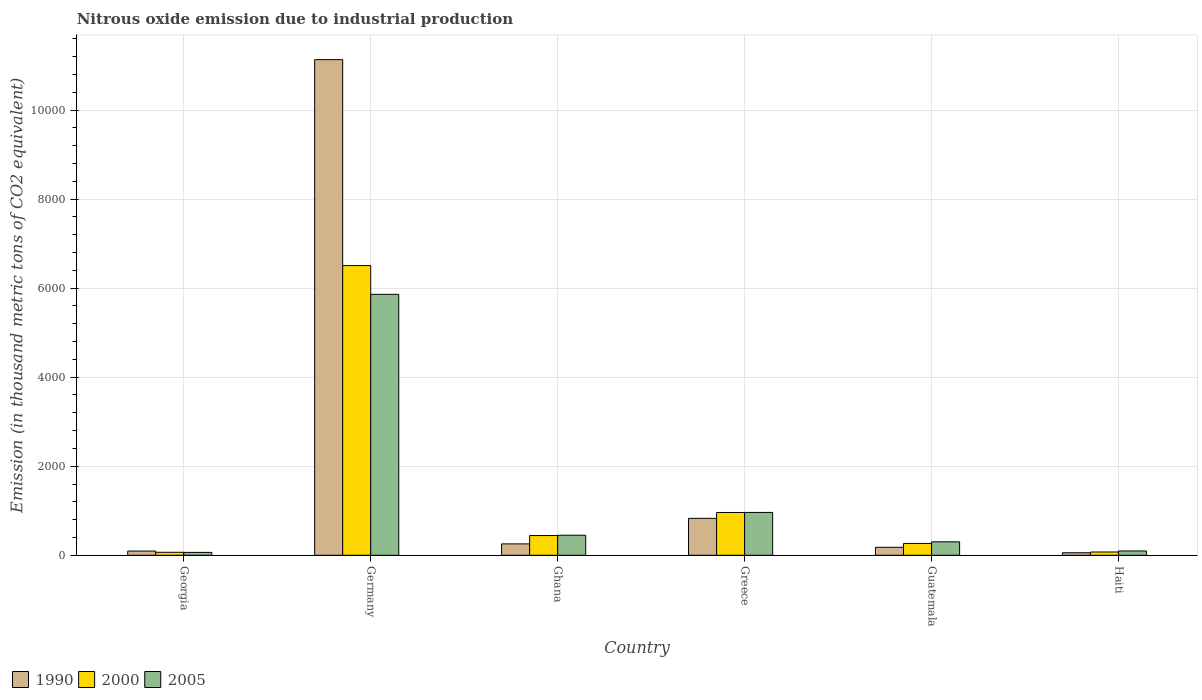How many different coloured bars are there?
Ensure brevity in your answer.  3. Are the number of bars per tick equal to the number of legend labels?
Offer a very short reply. Yes. How many bars are there on the 4th tick from the right?
Your response must be concise. 3. What is the label of the 5th group of bars from the left?
Make the answer very short. Guatemala. In how many cases, is the number of bars for a given country not equal to the number of legend labels?
Make the answer very short. 0. What is the amount of nitrous oxide emitted in 2000 in Haiti?
Provide a succinct answer. 73.8. Across all countries, what is the maximum amount of nitrous oxide emitted in 1990?
Provide a succinct answer. 1.11e+04. Across all countries, what is the minimum amount of nitrous oxide emitted in 2005?
Provide a short and direct response. 64.5. In which country was the amount of nitrous oxide emitted in 2005 maximum?
Offer a terse response. Germany. In which country was the amount of nitrous oxide emitted in 1990 minimum?
Ensure brevity in your answer.  Haiti. What is the total amount of nitrous oxide emitted in 2000 in the graph?
Keep it short and to the point. 8317.5. What is the difference between the amount of nitrous oxide emitted in 2000 in Germany and that in Greece?
Provide a short and direct response. 5546.2. What is the difference between the amount of nitrous oxide emitted in 1990 in Georgia and the amount of nitrous oxide emitted in 2005 in Guatemala?
Provide a succinct answer. -207.2. What is the average amount of nitrous oxide emitted in 1990 per country?
Provide a succinct answer. 2091.42. What is the difference between the amount of nitrous oxide emitted of/in 2005 and amount of nitrous oxide emitted of/in 2000 in Greece?
Offer a terse response. 1.7. What is the ratio of the amount of nitrous oxide emitted in 1990 in Georgia to that in Haiti?
Give a very brief answer. 1.68. Is the amount of nitrous oxide emitted in 2000 in Georgia less than that in Ghana?
Your response must be concise. Yes. Is the difference between the amount of nitrous oxide emitted in 2005 in Georgia and Germany greater than the difference between the amount of nitrous oxide emitted in 2000 in Georgia and Germany?
Give a very brief answer. Yes. What is the difference between the highest and the second highest amount of nitrous oxide emitted in 2000?
Ensure brevity in your answer.  -5546.2. What is the difference between the highest and the lowest amount of nitrous oxide emitted in 2000?
Your answer should be compact. 6439.8. In how many countries, is the amount of nitrous oxide emitted in 2000 greater than the average amount of nitrous oxide emitted in 2000 taken over all countries?
Provide a succinct answer. 1. What does the 3rd bar from the left in Greece represents?
Ensure brevity in your answer.  2005. Is it the case that in every country, the sum of the amount of nitrous oxide emitted in 1990 and amount of nitrous oxide emitted in 2000 is greater than the amount of nitrous oxide emitted in 2005?
Provide a short and direct response. Yes. How many bars are there?
Your response must be concise. 18. Are all the bars in the graph horizontal?
Provide a short and direct response. No. How many countries are there in the graph?
Offer a terse response. 6. What is the difference between two consecutive major ticks on the Y-axis?
Keep it short and to the point. 2000. Are the values on the major ticks of Y-axis written in scientific E-notation?
Provide a succinct answer. No. Does the graph contain any zero values?
Your answer should be compact. No. Does the graph contain grids?
Ensure brevity in your answer.  Yes. What is the title of the graph?
Your answer should be very brief. Nitrous oxide emission due to industrial production. Does "2014" appear as one of the legend labels in the graph?
Your response must be concise. No. What is the label or title of the Y-axis?
Offer a very short reply. Emission (in thousand metric tons of CO2 equivalent). What is the Emission (in thousand metric tons of CO2 equivalent) in 1990 in Georgia?
Your answer should be compact. 94.9. What is the Emission (in thousand metric tons of CO2 equivalent) of 2000 in Georgia?
Your answer should be very brief. 67.2. What is the Emission (in thousand metric tons of CO2 equivalent) in 2005 in Georgia?
Provide a short and direct response. 64.5. What is the Emission (in thousand metric tons of CO2 equivalent) in 1990 in Germany?
Ensure brevity in your answer.  1.11e+04. What is the Emission (in thousand metric tons of CO2 equivalent) of 2000 in Germany?
Provide a succinct answer. 6507. What is the Emission (in thousand metric tons of CO2 equivalent) in 2005 in Germany?
Keep it short and to the point. 5860.9. What is the Emission (in thousand metric tons of CO2 equivalent) of 1990 in Ghana?
Give a very brief answer. 256. What is the Emission (in thousand metric tons of CO2 equivalent) of 2000 in Ghana?
Your answer should be very brief. 443.1. What is the Emission (in thousand metric tons of CO2 equivalent) in 2005 in Ghana?
Offer a terse response. 449.9. What is the Emission (in thousand metric tons of CO2 equivalent) in 1990 in Greece?
Provide a succinct answer. 829.3. What is the Emission (in thousand metric tons of CO2 equivalent) of 2000 in Greece?
Your response must be concise. 960.8. What is the Emission (in thousand metric tons of CO2 equivalent) in 2005 in Greece?
Keep it short and to the point. 962.5. What is the Emission (in thousand metric tons of CO2 equivalent) of 1990 in Guatemala?
Your answer should be compact. 179.5. What is the Emission (in thousand metric tons of CO2 equivalent) of 2000 in Guatemala?
Give a very brief answer. 265.6. What is the Emission (in thousand metric tons of CO2 equivalent) in 2005 in Guatemala?
Keep it short and to the point. 302.1. What is the Emission (in thousand metric tons of CO2 equivalent) of 1990 in Haiti?
Keep it short and to the point. 56.6. What is the Emission (in thousand metric tons of CO2 equivalent) in 2000 in Haiti?
Your answer should be very brief. 73.8. What is the Emission (in thousand metric tons of CO2 equivalent) in 2005 in Haiti?
Your answer should be compact. 97. Across all countries, what is the maximum Emission (in thousand metric tons of CO2 equivalent) in 1990?
Provide a short and direct response. 1.11e+04. Across all countries, what is the maximum Emission (in thousand metric tons of CO2 equivalent) in 2000?
Make the answer very short. 6507. Across all countries, what is the maximum Emission (in thousand metric tons of CO2 equivalent) in 2005?
Your answer should be very brief. 5860.9. Across all countries, what is the minimum Emission (in thousand metric tons of CO2 equivalent) of 1990?
Your answer should be compact. 56.6. Across all countries, what is the minimum Emission (in thousand metric tons of CO2 equivalent) in 2000?
Provide a short and direct response. 67.2. Across all countries, what is the minimum Emission (in thousand metric tons of CO2 equivalent) of 2005?
Your answer should be compact. 64.5. What is the total Emission (in thousand metric tons of CO2 equivalent) in 1990 in the graph?
Ensure brevity in your answer.  1.25e+04. What is the total Emission (in thousand metric tons of CO2 equivalent) in 2000 in the graph?
Your response must be concise. 8317.5. What is the total Emission (in thousand metric tons of CO2 equivalent) of 2005 in the graph?
Provide a succinct answer. 7736.9. What is the difference between the Emission (in thousand metric tons of CO2 equivalent) in 1990 in Georgia and that in Germany?
Make the answer very short. -1.10e+04. What is the difference between the Emission (in thousand metric tons of CO2 equivalent) in 2000 in Georgia and that in Germany?
Provide a short and direct response. -6439.8. What is the difference between the Emission (in thousand metric tons of CO2 equivalent) in 2005 in Georgia and that in Germany?
Keep it short and to the point. -5796.4. What is the difference between the Emission (in thousand metric tons of CO2 equivalent) in 1990 in Georgia and that in Ghana?
Your response must be concise. -161.1. What is the difference between the Emission (in thousand metric tons of CO2 equivalent) of 2000 in Georgia and that in Ghana?
Offer a very short reply. -375.9. What is the difference between the Emission (in thousand metric tons of CO2 equivalent) of 2005 in Georgia and that in Ghana?
Provide a short and direct response. -385.4. What is the difference between the Emission (in thousand metric tons of CO2 equivalent) of 1990 in Georgia and that in Greece?
Make the answer very short. -734.4. What is the difference between the Emission (in thousand metric tons of CO2 equivalent) in 2000 in Georgia and that in Greece?
Give a very brief answer. -893.6. What is the difference between the Emission (in thousand metric tons of CO2 equivalent) of 2005 in Georgia and that in Greece?
Offer a terse response. -898. What is the difference between the Emission (in thousand metric tons of CO2 equivalent) in 1990 in Georgia and that in Guatemala?
Provide a succinct answer. -84.6. What is the difference between the Emission (in thousand metric tons of CO2 equivalent) in 2000 in Georgia and that in Guatemala?
Your answer should be very brief. -198.4. What is the difference between the Emission (in thousand metric tons of CO2 equivalent) of 2005 in Georgia and that in Guatemala?
Give a very brief answer. -237.6. What is the difference between the Emission (in thousand metric tons of CO2 equivalent) in 1990 in Georgia and that in Haiti?
Make the answer very short. 38.3. What is the difference between the Emission (in thousand metric tons of CO2 equivalent) of 2000 in Georgia and that in Haiti?
Your response must be concise. -6.6. What is the difference between the Emission (in thousand metric tons of CO2 equivalent) of 2005 in Georgia and that in Haiti?
Keep it short and to the point. -32.5. What is the difference between the Emission (in thousand metric tons of CO2 equivalent) in 1990 in Germany and that in Ghana?
Provide a succinct answer. 1.09e+04. What is the difference between the Emission (in thousand metric tons of CO2 equivalent) of 2000 in Germany and that in Ghana?
Give a very brief answer. 6063.9. What is the difference between the Emission (in thousand metric tons of CO2 equivalent) in 2005 in Germany and that in Ghana?
Your answer should be compact. 5411. What is the difference between the Emission (in thousand metric tons of CO2 equivalent) of 1990 in Germany and that in Greece?
Give a very brief answer. 1.03e+04. What is the difference between the Emission (in thousand metric tons of CO2 equivalent) of 2000 in Germany and that in Greece?
Provide a succinct answer. 5546.2. What is the difference between the Emission (in thousand metric tons of CO2 equivalent) in 2005 in Germany and that in Greece?
Your answer should be very brief. 4898.4. What is the difference between the Emission (in thousand metric tons of CO2 equivalent) in 1990 in Germany and that in Guatemala?
Keep it short and to the point. 1.10e+04. What is the difference between the Emission (in thousand metric tons of CO2 equivalent) in 2000 in Germany and that in Guatemala?
Offer a very short reply. 6241.4. What is the difference between the Emission (in thousand metric tons of CO2 equivalent) of 2005 in Germany and that in Guatemala?
Your response must be concise. 5558.8. What is the difference between the Emission (in thousand metric tons of CO2 equivalent) of 1990 in Germany and that in Haiti?
Offer a terse response. 1.11e+04. What is the difference between the Emission (in thousand metric tons of CO2 equivalent) in 2000 in Germany and that in Haiti?
Ensure brevity in your answer.  6433.2. What is the difference between the Emission (in thousand metric tons of CO2 equivalent) of 2005 in Germany and that in Haiti?
Ensure brevity in your answer.  5763.9. What is the difference between the Emission (in thousand metric tons of CO2 equivalent) of 1990 in Ghana and that in Greece?
Provide a succinct answer. -573.3. What is the difference between the Emission (in thousand metric tons of CO2 equivalent) in 2000 in Ghana and that in Greece?
Provide a short and direct response. -517.7. What is the difference between the Emission (in thousand metric tons of CO2 equivalent) in 2005 in Ghana and that in Greece?
Offer a terse response. -512.6. What is the difference between the Emission (in thousand metric tons of CO2 equivalent) in 1990 in Ghana and that in Guatemala?
Keep it short and to the point. 76.5. What is the difference between the Emission (in thousand metric tons of CO2 equivalent) in 2000 in Ghana and that in Guatemala?
Your answer should be very brief. 177.5. What is the difference between the Emission (in thousand metric tons of CO2 equivalent) in 2005 in Ghana and that in Guatemala?
Make the answer very short. 147.8. What is the difference between the Emission (in thousand metric tons of CO2 equivalent) in 1990 in Ghana and that in Haiti?
Give a very brief answer. 199.4. What is the difference between the Emission (in thousand metric tons of CO2 equivalent) in 2000 in Ghana and that in Haiti?
Make the answer very short. 369.3. What is the difference between the Emission (in thousand metric tons of CO2 equivalent) of 2005 in Ghana and that in Haiti?
Offer a terse response. 352.9. What is the difference between the Emission (in thousand metric tons of CO2 equivalent) in 1990 in Greece and that in Guatemala?
Offer a terse response. 649.8. What is the difference between the Emission (in thousand metric tons of CO2 equivalent) in 2000 in Greece and that in Guatemala?
Provide a short and direct response. 695.2. What is the difference between the Emission (in thousand metric tons of CO2 equivalent) of 2005 in Greece and that in Guatemala?
Keep it short and to the point. 660.4. What is the difference between the Emission (in thousand metric tons of CO2 equivalent) in 1990 in Greece and that in Haiti?
Your answer should be compact. 772.7. What is the difference between the Emission (in thousand metric tons of CO2 equivalent) in 2000 in Greece and that in Haiti?
Provide a succinct answer. 887. What is the difference between the Emission (in thousand metric tons of CO2 equivalent) of 2005 in Greece and that in Haiti?
Keep it short and to the point. 865.5. What is the difference between the Emission (in thousand metric tons of CO2 equivalent) in 1990 in Guatemala and that in Haiti?
Provide a short and direct response. 122.9. What is the difference between the Emission (in thousand metric tons of CO2 equivalent) of 2000 in Guatemala and that in Haiti?
Make the answer very short. 191.8. What is the difference between the Emission (in thousand metric tons of CO2 equivalent) in 2005 in Guatemala and that in Haiti?
Make the answer very short. 205.1. What is the difference between the Emission (in thousand metric tons of CO2 equivalent) of 1990 in Georgia and the Emission (in thousand metric tons of CO2 equivalent) of 2000 in Germany?
Offer a very short reply. -6412.1. What is the difference between the Emission (in thousand metric tons of CO2 equivalent) in 1990 in Georgia and the Emission (in thousand metric tons of CO2 equivalent) in 2005 in Germany?
Keep it short and to the point. -5766. What is the difference between the Emission (in thousand metric tons of CO2 equivalent) in 2000 in Georgia and the Emission (in thousand metric tons of CO2 equivalent) in 2005 in Germany?
Offer a very short reply. -5793.7. What is the difference between the Emission (in thousand metric tons of CO2 equivalent) of 1990 in Georgia and the Emission (in thousand metric tons of CO2 equivalent) of 2000 in Ghana?
Give a very brief answer. -348.2. What is the difference between the Emission (in thousand metric tons of CO2 equivalent) of 1990 in Georgia and the Emission (in thousand metric tons of CO2 equivalent) of 2005 in Ghana?
Your response must be concise. -355. What is the difference between the Emission (in thousand metric tons of CO2 equivalent) in 2000 in Georgia and the Emission (in thousand metric tons of CO2 equivalent) in 2005 in Ghana?
Provide a succinct answer. -382.7. What is the difference between the Emission (in thousand metric tons of CO2 equivalent) in 1990 in Georgia and the Emission (in thousand metric tons of CO2 equivalent) in 2000 in Greece?
Keep it short and to the point. -865.9. What is the difference between the Emission (in thousand metric tons of CO2 equivalent) of 1990 in Georgia and the Emission (in thousand metric tons of CO2 equivalent) of 2005 in Greece?
Ensure brevity in your answer.  -867.6. What is the difference between the Emission (in thousand metric tons of CO2 equivalent) in 2000 in Georgia and the Emission (in thousand metric tons of CO2 equivalent) in 2005 in Greece?
Keep it short and to the point. -895.3. What is the difference between the Emission (in thousand metric tons of CO2 equivalent) of 1990 in Georgia and the Emission (in thousand metric tons of CO2 equivalent) of 2000 in Guatemala?
Offer a very short reply. -170.7. What is the difference between the Emission (in thousand metric tons of CO2 equivalent) of 1990 in Georgia and the Emission (in thousand metric tons of CO2 equivalent) of 2005 in Guatemala?
Your answer should be compact. -207.2. What is the difference between the Emission (in thousand metric tons of CO2 equivalent) in 2000 in Georgia and the Emission (in thousand metric tons of CO2 equivalent) in 2005 in Guatemala?
Your answer should be very brief. -234.9. What is the difference between the Emission (in thousand metric tons of CO2 equivalent) in 1990 in Georgia and the Emission (in thousand metric tons of CO2 equivalent) in 2000 in Haiti?
Your answer should be very brief. 21.1. What is the difference between the Emission (in thousand metric tons of CO2 equivalent) in 1990 in Georgia and the Emission (in thousand metric tons of CO2 equivalent) in 2005 in Haiti?
Your response must be concise. -2.1. What is the difference between the Emission (in thousand metric tons of CO2 equivalent) in 2000 in Georgia and the Emission (in thousand metric tons of CO2 equivalent) in 2005 in Haiti?
Your response must be concise. -29.8. What is the difference between the Emission (in thousand metric tons of CO2 equivalent) in 1990 in Germany and the Emission (in thousand metric tons of CO2 equivalent) in 2000 in Ghana?
Your response must be concise. 1.07e+04. What is the difference between the Emission (in thousand metric tons of CO2 equivalent) in 1990 in Germany and the Emission (in thousand metric tons of CO2 equivalent) in 2005 in Ghana?
Your answer should be very brief. 1.07e+04. What is the difference between the Emission (in thousand metric tons of CO2 equivalent) in 2000 in Germany and the Emission (in thousand metric tons of CO2 equivalent) in 2005 in Ghana?
Give a very brief answer. 6057.1. What is the difference between the Emission (in thousand metric tons of CO2 equivalent) of 1990 in Germany and the Emission (in thousand metric tons of CO2 equivalent) of 2000 in Greece?
Your answer should be compact. 1.02e+04. What is the difference between the Emission (in thousand metric tons of CO2 equivalent) in 1990 in Germany and the Emission (in thousand metric tons of CO2 equivalent) in 2005 in Greece?
Provide a short and direct response. 1.02e+04. What is the difference between the Emission (in thousand metric tons of CO2 equivalent) of 2000 in Germany and the Emission (in thousand metric tons of CO2 equivalent) of 2005 in Greece?
Give a very brief answer. 5544.5. What is the difference between the Emission (in thousand metric tons of CO2 equivalent) of 1990 in Germany and the Emission (in thousand metric tons of CO2 equivalent) of 2000 in Guatemala?
Give a very brief answer. 1.09e+04. What is the difference between the Emission (in thousand metric tons of CO2 equivalent) in 1990 in Germany and the Emission (in thousand metric tons of CO2 equivalent) in 2005 in Guatemala?
Your answer should be very brief. 1.08e+04. What is the difference between the Emission (in thousand metric tons of CO2 equivalent) in 2000 in Germany and the Emission (in thousand metric tons of CO2 equivalent) in 2005 in Guatemala?
Give a very brief answer. 6204.9. What is the difference between the Emission (in thousand metric tons of CO2 equivalent) in 1990 in Germany and the Emission (in thousand metric tons of CO2 equivalent) in 2000 in Haiti?
Your response must be concise. 1.11e+04. What is the difference between the Emission (in thousand metric tons of CO2 equivalent) in 1990 in Germany and the Emission (in thousand metric tons of CO2 equivalent) in 2005 in Haiti?
Keep it short and to the point. 1.10e+04. What is the difference between the Emission (in thousand metric tons of CO2 equivalent) in 2000 in Germany and the Emission (in thousand metric tons of CO2 equivalent) in 2005 in Haiti?
Keep it short and to the point. 6410. What is the difference between the Emission (in thousand metric tons of CO2 equivalent) in 1990 in Ghana and the Emission (in thousand metric tons of CO2 equivalent) in 2000 in Greece?
Your answer should be compact. -704.8. What is the difference between the Emission (in thousand metric tons of CO2 equivalent) in 1990 in Ghana and the Emission (in thousand metric tons of CO2 equivalent) in 2005 in Greece?
Your response must be concise. -706.5. What is the difference between the Emission (in thousand metric tons of CO2 equivalent) of 2000 in Ghana and the Emission (in thousand metric tons of CO2 equivalent) of 2005 in Greece?
Your answer should be compact. -519.4. What is the difference between the Emission (in thousand metric tons of CO2 equivalent) of 1990 in Ghana and the Emission (in thousand metric tons of CO2 equivalent) of 2000 in Guatemala?
Your answer should be compact. -9.6. What is the difference between the Emission (in thousand metric tons of CO2 equivalent) of 1990 in Ghana and the Emission (in thousand metric tons of CO2 equivalent) of 2005 in Guatemala?
Give a very brief answer. -46.1. What is the difference between the Emission (in thousand metric tons of CO2 equivalent) in 2000 in Ghana and the Emission (in thousand metric tons of CO2 equivalent) in 2005 in Guatemala?
Provide a short and direct response. 141. What is the difference between the Emission (in thousand metric tons of CO2 equivalent) of 1990 in Ghana and the Emission (in thousand metric tons of CO2 equivalent) of 2000 in Haiti?
Give a very brief answer. 182.2. What is the difference between the Emission (in thousand metric tons of CO2 equivalent) of 1990 in Ghana and the Emission (in thousand metric tons of CO2 equivalent) of 2005 in Haiti?
Offer a terse response. 159. What is the difference between the Emission (in thousand metric tons of CO2 equivalent) in 2000 in Ghana and the Emission (in thousand metric tons of CO2 equivalent) in 2005 in Haiti?
Keep it short and to the point. 346.1. What is the difference between the Emission (in thousand metric tons of CO2 equivalent) of 1990 in Greece and the Emission (in thousand metric tons of CO2 equivalent) of 2000 in Guatemala?
Your answer should be very brief. 563.7. What is the difference between the Emission (in thousand metric tons of CO2 equivalent) in 1990 in Greece and the Emission (in thousand metric tons of CO2 equivalent) in 2005 in Guatemala?
Ensure brevity in your answer.  527.2. What is the difference between the Emission (in thousand metric tons of CO2 equivalent) of 2000 in Greece and the Emission (in thousand metric tons of CO2 equivalent) of 2005 in Guatemala?
Give a very brief answer. 658.7. What is the difference between the Emission (in thousand metric tons of CO2 equivalent) of 1990 in Greece and the Emission (in thousand metric tons of CO2 equivalent) of 2000 in Haiti?
Keep it short and to the point. 755.5. What is the difference between the Emission (in thousand metric tons of CO2 equivalent) of 1990 in Greece and the Emission (in thousand metric tons of CO2 equivalent) of 2005 in Haiti?
Ensure brevity in your answer.  732.3. What is the difference between the Emission (in thousand metric tons of CO2 equivalent) of 2000 in Greece and the Emission (in thousand metric tons of CO2 equivalent) of 2005 in Haiti?
Your answer should be compact. 863.8. What is the difference between the Emission (in thousand metric tons of CO2 equivalent) of 1990 in Guatemala and the Emission (in thousand metric tons of CO2 equivalent) of 2000 in Haiti?
Provide a short and direct response. 105.7. What is the difference between the Emission (in thousand metric tons of CO2 equivalent) of 1990 in Guatemala and the Emission (in thousand metric tons of CO2 equivalent) of 2005 in Haiti?
Your response must be concise. 82.5. What is the difference between the Emission (in thousand metric tons of CO2 equivalent) of 2000 in Guatemala and the Emission (in thousand metric tons of CO2 equivalent) of 2005 in Haiti?
Offer a very short reply. 168.6. What is the average Emission (in thousand metric tons of CO2 equivalent) of 1990 per country?
Ensure brevity in your answer.  2091.42. What is the average Emission (in thousand metric tons of CO2 equivalent) of 2000 per country?
Offer a very short reply. 1386.25. What is the average Emission (in thousand metric tons of CO2 equivalent) in 2005 per country?
Ensure brevity in your answer.  1289.48. What is the difference between the Emission (in thousand metric tons of CO2 equivalent) in 1990 and Emission (in thousand metric tons of CO2 equivalent) in 2000 in Georgia?
Provide a succinct answer. 27.7. What is the difference between the Emission (in thousand metric tons of CO2 equivalent) in 1990 and Emission (in thousand metric tons of CO2 equivalent) in 2005 in Georgia?
Keep it short and to the point. 30.4. What is the difference between the Emission (in thousand metric tons of CO2 equivalent) of 2000 and Emission (in thousand metric tons of CO2 equivalent) of 2005 in Georgia?
Offer a very short reply. 2.7. What is the difference between the Emission (in thousand metric tons of CO2 equivalent) in 1990 and Emission (in thousand metric tons of CO2 equivalent) in 2000 in Germany?
Provide a short and direct response. 4625.2. What is the difference between the Emission (in thousand metric tons of CO2 equivalent) of 1990 and Emission (in thousand metric tons of CO2 equivalent) of 2005 in Germany?
Make the answer very short. 5271.3. What is the difference between the Emission (in thousand metric tons of CO2 equivalent) in 2000 and Emission (in thousand metric tons of CO2 equivalent) in 2005 in Germany?
Provide a succinct answer. 646.1. What is the difference between the Emission (in thousand metric tons of CO2 equivalent) of 1990 and Emission (in thousand metric tons of CO2 equivalent) of 2000 in Ghana?
Your response must be concise. -187.1. What is the difference between the Emission (in thousand metric tons of CO2 equivalent) in 1990 and Emission (in thousand metric tons of CO2 equivalent) in 2005 in Ghana?
Keep it short and to the point. -193.9. What is the difference between the Emission (in thousand metric tons of CO2 equivalent) in 2000 and Emission (in thousand metric tons of CO2 equivalent) in 2005 in Ghana?
Your answer should be very brief. -6.8. What is the difference between the Emission (in thousand metric tons of CO2 equivalent) in 1990 and Emission (in thousand metric tons of CO2 equivalent) in 2000 in Greece?
Your answer should be very brief. -131.5. What is the difference between the Emission (in thousand metric tons of CO2 equivalent) of 1990 and Emission (in thousand metric tons of CO2 equivalent) of 2005 in Greece?
Keep it short and to the point. -133.2. What is the difference between the Emission (in thousand metric tons of CO2 equivalent) of 2000 and Emission (in thousand metric tons of CO2 equivalent) of 2005 in Greece?
Your answer should be very brief. -1.7. What is the difference between the Emission (in thousand metric tons of CO2 equivalent) of 1990 and Emission (in thousand metric tons of CO2 equivalent) of 2000 in Guatemala?
Provide a succinct answer. -86.1. What is the difference between the Emission (in thousand metric tons of CO2 equivalent) of 1990 and Emission (in thousand metric tons of CO2 equivalent) of 2005 in Guatemala?
Your response must be concise. -122.6. What is the difference between the Emission (in thousand metric tons of CO2 equivalent) in 2000 and Emission (in thousand metric tons of CO2 equivalent) in 2005 in Guatemala?
Ensure brevity in your answer.  -36.5. What is the difference between the Emission (in thousand metric tons of CO2 equivalent) in 1990 and Emission (in thousand metric tons of CO2 equivalent) in 2000 in Haiti?
Your answer should be very brief. -17.2. What is the difference between the Emission (in thousand metric tons of CO2 equivalent) in 1990 and Emission (in thousand metric tons of CO2 equivalent) in 2005 in Haiti?
Your answer should be very brief. -40.4. What is the difference between the Emission (in thousand metric tons of CO2 equivalent) in 2000 and Emission (in thousand metric tons of CO2 equivalent) in 2005 in Haiti?
Your answer should be compact. -23.2. What is the ratio of the Emission (in thousand metric tons of CO2 equivalent) in 1990 in Georgia to that in Germany?
Your response must be concise. 0.01. What is the ratio of the Emission (in thousand metric tons of CO2 equivalent) in 2000 in Georgia to that in Germany?
Offer a terse response. 0.01. What is the ratio of the Emission (in thousand metric tons of CO2 equivalent) of 2005 in Georgia to that in Germany?
Ensure brevity in your answer.  0.01. What is the ratio of the Emission (in thousand metric tons of CO2 equivalent) in 1990 in Georgia to that in Ghana?
Offer a very short reply. 0.37. What is the ratio of the Emission (in thousand metric tons of CO2 equivalent) in 2000 in Georgia to that in Ghana?
Make the answer very short. 0.15. What is the ratio of the Emission (in thousand metric tons of CO2 equivalent) in 2005 in Georgia to that in Ghana?
Your response must be concise. 0.14. What is the ratio of the Emission (in thousand metric tons of CO2 equivalent) of 1990 in Georgia to that in Greece?
Your response must be concise. 0.11. What is the ratio of the Emission (in thousand metric tons of CO2 equivalent) in 2000 in Georgia to that in Greece?
Your answer should be compact. 0.07. What is the ratio of the Emission (in thousand metric tons of CO2 equivalent) in 2005 in Georgia to that in Greece?
Ensure brevity in your answer.  0.07. What is the ratio of the Emission (in thousand metric tons of CO2 equivalent) in 1990 in Georgia to that in Guatemala?
Your answer should be very brief. 0.53. What is the ratio of the Emission (in thousand metric tons of CO2 equivalent) of 2000 in Georgia to that in Guatemala?
Make the answer very short. 0.25. What is the ratio of the Emission (in thousand metric tons of CO2 equivalent) of 2005 in Georgia to that in Guatemala?
Your answer should be very brief. 0.21. What is the ratio of the Emission (in thousand metric tons of CO2 equivalent) of 1990 in Georgia to that in Haiti?
Give a very brief answer. 1.68. What is the ratio of the Emission (in thousand metric tons of CO2 equivalent) of 2000 in Georgia to that in Haiti?
Offer a very short reply. 0.91. What is the ratio of the Emission (in thousand metric tons of CO2 equivalent) of 2005 in Georgia to that in Haiti?
Offer a terse response. 0.66. What is the ratio of the Emission (in thousand metric tons of CO2 equivalent) of 1990 in Germany to that in Ghana?
Keep it short and to the point. 43.49. What is the ratio of the Emission (in thousand metric tons of CO2 equivalent) of 2000 in Germany to that in Ghana?
Your answer should be compact. 14.69. What is the ratio of the Emission (in thousand metric tons of CO2 equivalent) of 2005 in Germany to that in Ghana?
Keep it short and to the point. 13.03. What is the ratio of the Emission (in thousand metric tons of CO2 equivalent) in 1990 in Germany to that in Greece?
Provide a succinct answer. 13.42. What is the ratio of the Emission (in thousand metric tons of CO2 equivalent) in 2000 in Germany to that in Greece?
Provide a short and direct response. 6.77. What is the ratio of the Emission (in thousand metric tons of CO2 equivalent) in 2005 in Germany to that in Greece?
Make the answer very short. 6.09. What is the ratio of the Emission (in thousand metric tons of CO2 equivalent) in 1990 in Germany to that in Guatemala?
Your answer should be compact. 62.02. What is the ratio of the Emission (in thousand metric tons of CO2 equivalent) of 2000 in Germany to that in Guatemala?
Keep it short and to the point. 24.5. What is the ratio of the Emission (in thousand metric tons of CO2 equivalent) in 2005 in Germany to that in Guatemala?
Your answer should be compact. 19.4. What is the ratio of the Emission (in thousand metric tons of CO2 equivalent) in 1990 in Germany to that in Haiti?
Ensure brevity in your answer.  196.68. What is the ratio of the Emission (in thousand metric tons of CO2 equivalent) in 2000 in Germany to that in Haiti?
Your answer should be compact. 88.17. What is the ratio of the Emission (in thousand metric tons of CO2 equivalent) of 2005 in Germany to that in Haiti?
Ensure brevity in your answer.  60.42. What is the ratio of the Emission (in thousand metric tons of CO2 equivalent) in 1990 in Ghana to that in Greece?
Offer a terse response. 0.31. What is the ratio of the Emission (in thousand metric tons of CO2 equivalent) in 2000 in Ghana to that in Greece?
Your answer should be very brief. 0.46. What is the ratio of the Emission (in thousand metric tons of CO2 equivalent) of 2005 in Ghana to that in Greece?
Ensure brevity in your answer.  0.47. What is the ratio of the Emission (in thousand metric tons of CO2 equivalent) of 1990 in Ghana to that in Guatemala?
Ensure brevity in your answer.  1.43. What is the ratio of the Emission (in thousand metric tons of CO2 equivalent) in 2000 in Ghana to that in Guatemala?
Ensure brevity in your answer.  1.67. What is the ratio of the Emission (in thousand metric tons of CO2 equivalent) of 2005 in Ghana to that in Guatemala?
Your answer should be compact. 1.49. What is the ratio of the Emission (in thousand metric tons of CO2 equivalent) of 1990 in Ghana to that in Haiti?
Your answer should be very brief. 4.52. What is the ratio of the Emission (in thousand metric tons of CO2 equivalent) of 2000 in Ghana to that in Haiti?
Make the answer very short. 6. What is the ratio of the Emission (in thousand metric tons of CO2 equivalent) in 2005 in Ghana to that in Haiti?
Offer a very short reply. 4.64. What is the ratio of the Emission (in thousand metric tons of CO2 equivalent) of 1990 in Greece to that in Guatemala?
Keep it short and to the point. 4.62. What is the ratio of the Emission (in thousand metric tons of CO2 equivalent) of 2000 in Greece to that in Guatemala?
Offer a terse response. 3.62. What is the ratio of the Emission (in thousand metric tons of CO2 equivalent) of 2005 in Greece to that in Guatemala?
Offer a very short reply. 3.19. What is the ratio of the Emission (in thousand metric tons of CO2 equivalent) in 1990 in Greece to that in Haiti?
Give a very brief answer. 14.65. What is the ratio of the Emission (in thousand metric tons of CO2 equivalent) in 2000 in Greece to that in Haiti?
Make the answer very short. 13.02. What is the ratio of the Emission (in thousand metric tons of CO2 equivalent) of 2005 in Greece to that in Haiti?
Your answer should be compact. 9.92. What is the ratio of the Emission (in thousand metric tons of CO2 equivalent) of 1990 in Guatemala to that in Haiti?
Offer a very short reply. 3.17. What is the ratio of the Emission (in thousand metric tons of CO2 equivalent) in 2000 in Guatemala to that in Haiti?
Your response must be concise. 3.6. What is the ratio of the Emission (in thousand metric tons of CO2 equivalent) of 2005 in Guatemala to that in Haiti?
Offer a terse response. 3.11. What is the difference between the highest and the second highest Emission (in thousand metric tons of CO2 equivalent) in 1990?
Provide a succinct answer. 1.03e+04. What is the difference between the highest and the second highest Emission (in thousand metric tons of CO2 equivalent) of 2000?
Your answer should be compact. 5546.2. What is the difference between the highest and the second highest Emission (in thousand metric tons of CO2 equivalent) of 2005?
Provide a succinct answer. 4898.4. What is the difference between the highest and the lowest Emission (in thousand metric tons of CO2 equivalent) of 1990?
Your answer should be very brief. 1.11e+04. What is the difference between the highest and the lowest Emission (in thousand metric tons of CO2 equivalent) in 2000?
Your answer should be compact. 6439.8. What is the difference between the highest and the lowest Emission (in thousand metric tons of CO2 equivalent) of 2005?
Make the answer very short. 5796.4. 